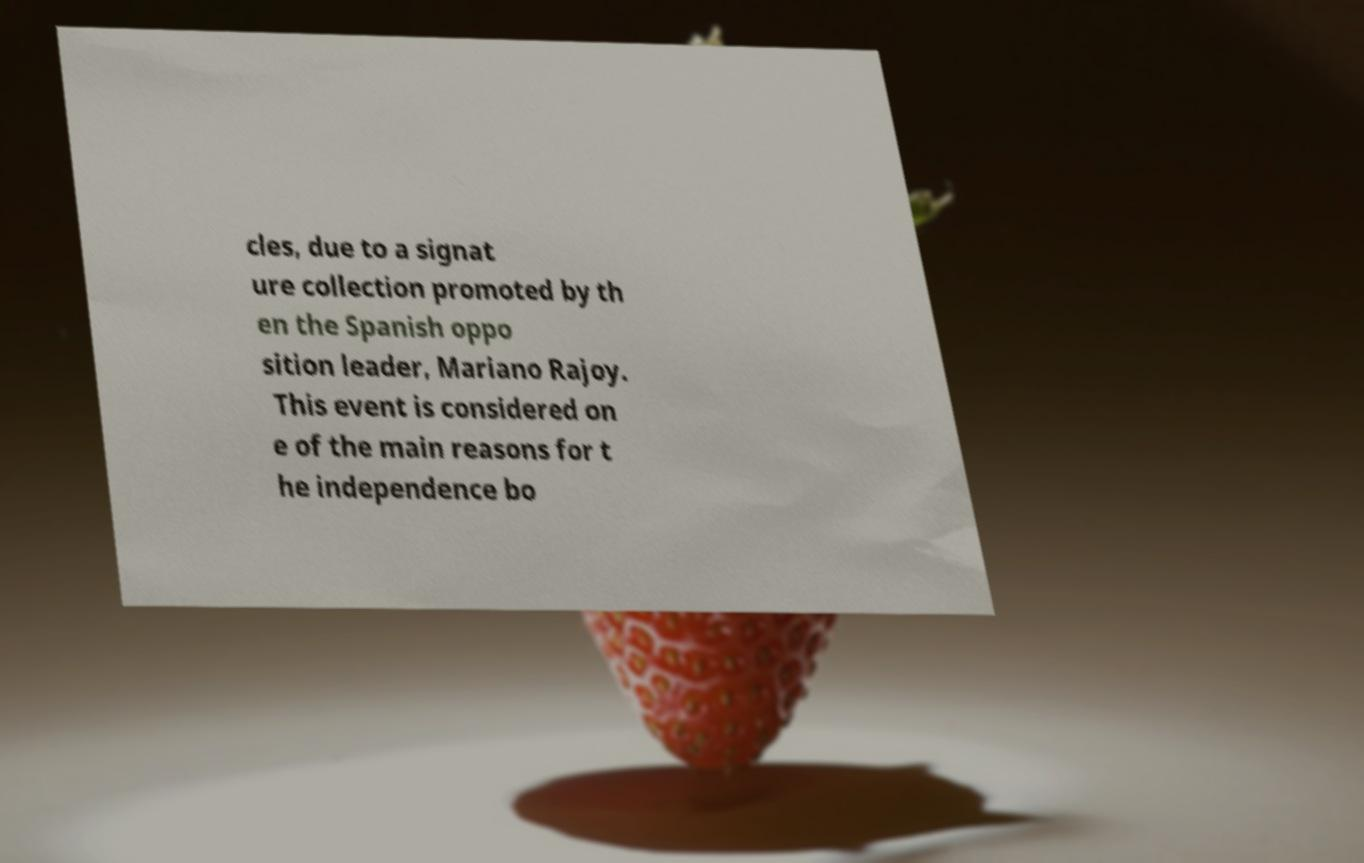What messages or text are displayed in this image? I need them in a readable, typed format. cles, due to a signat ure collection promoted by th en the Spanish oppo sition leader, Mariano Rajoy. This event is considered on e of the main reasons for t he independence bo 